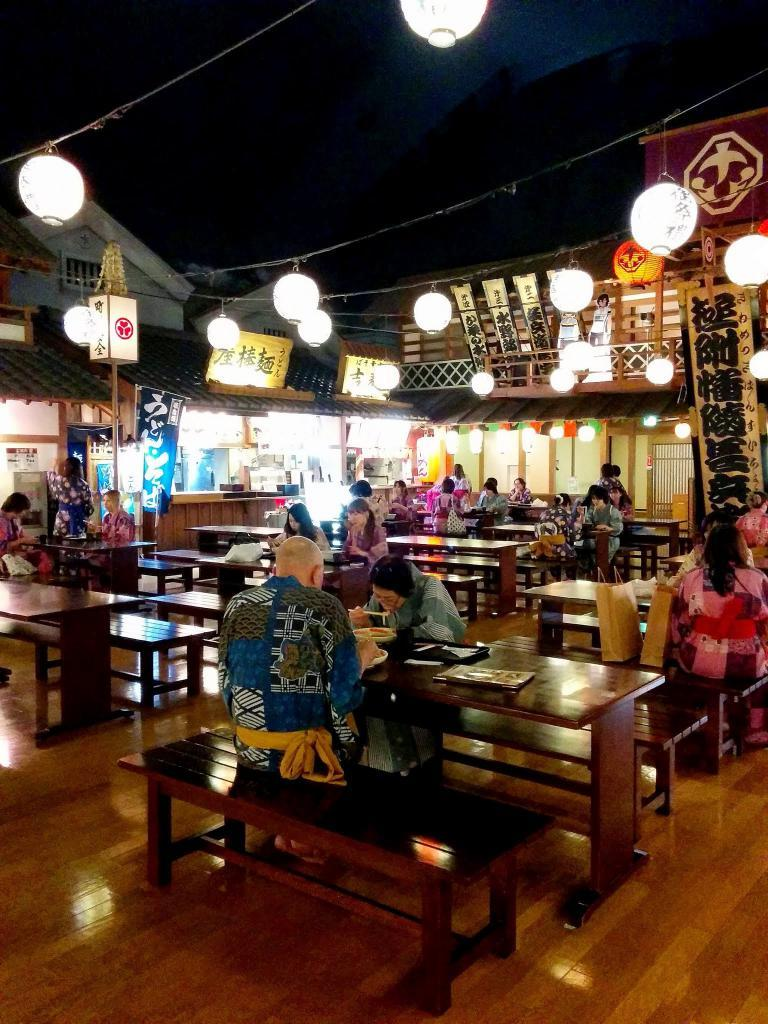What type of seating is available in the image? There are benches in the image. Are the benches occupied? Yes, people are sitting on the benches. What can be seen as decoration in the image? There are lights as decoration in the image. What type of structures are visible in the image? There are buildings visible in the image. What type of pie is being served on the shelf in the image? There is no pie or shelf present in the image. 